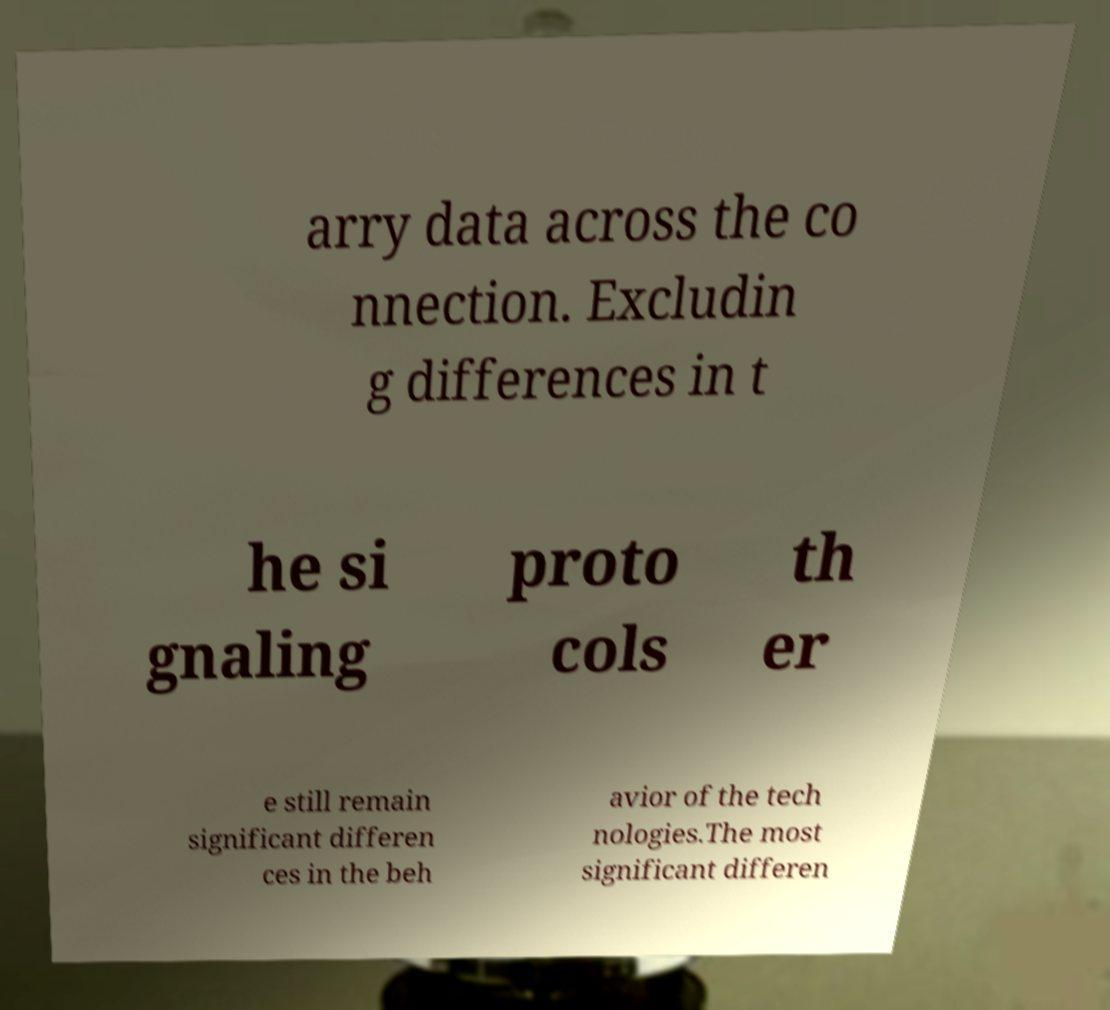For documentation purposes, I need the text within this image transcribed. Could you provide that? arry data across the co nnection. Excludin g differences in t he si gnaling proto cols th er e still remain significant differen ces in the beh avior of the tech nologies.The most significant differen 